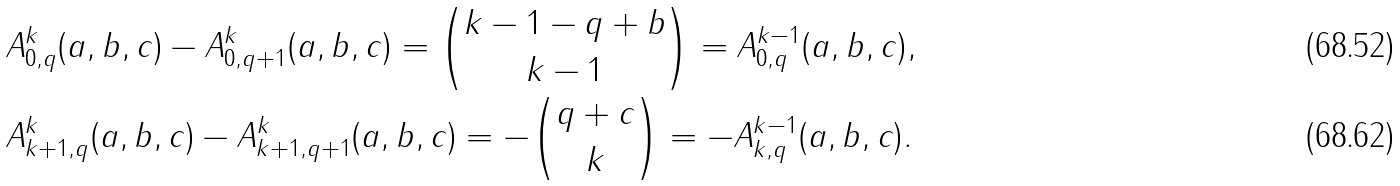<formula> <loc_0><loc_0><loc_500><loc_500>& A _ { 0 , q } ^ { k } ( a , b , c ) - A _ { 0 , q + 1 } ^ { k } ( a , b , c ) = \binom { k - 1 - q + b } { k - 1 } = A ^ { k - 1 } _ { 0 , q } ( a , b , c ) , \\ & A _ { k + 1 , q } ^ { k } ( a , b , c ) - A _ { k + 1 , q + 1 } ^ { k } ( a , b , c ) = - \binom { q + c } { k } = - A ^ { k - 1 } _ { k , q } ( a , b , c ) .</formula> 